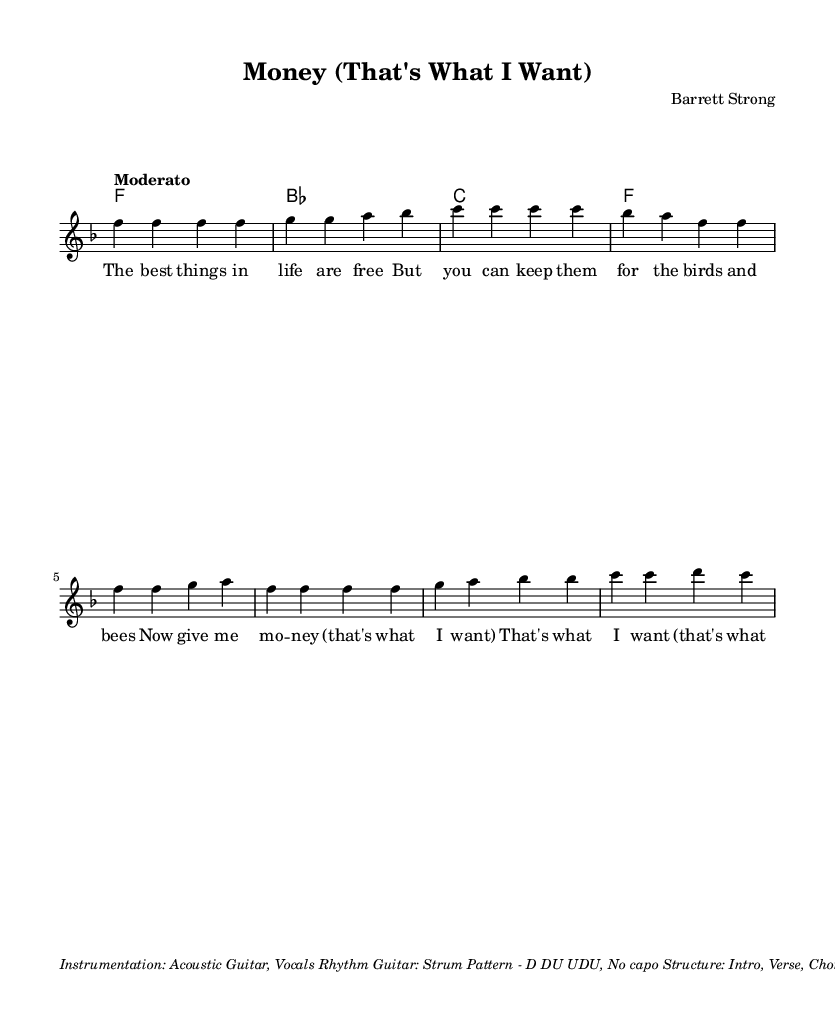What is the key signature of this music? The key signature is F major, which has one flat (B flat).
Answer: F major What is the time signature of this music? The time signature indicated is 4/4, meaning there are four beats in each measure.
Answer: 4/4 What is the tempo marking for this piece? The tempo marking is "Moderato," which suggests a moderate pace of play.
Answer: Moderato How many measures are in the chorus section? The chorus consists of 4 measures as indicated by the repeated section of music.
Answer: 4 What is the main instrumentation for this piece? The instrumentation listed includes Acoustic Guitar and Vocals, which are typical for folk music.
Answer: Acoustic Guitar, Vocals What is the strum pattern indicated for the rhythm guitar? The strum pattern is specified as D DU UDU, which details the down and up strokes for guitar playing.
Answer: D DU UDU How many verses are in the overall structure of the song? The structure includes two verses as indicated in the outline (Intro, Verse, Chorus, Verse, Chorus, Bridge, Chorus, Outro).
Answer: 2 